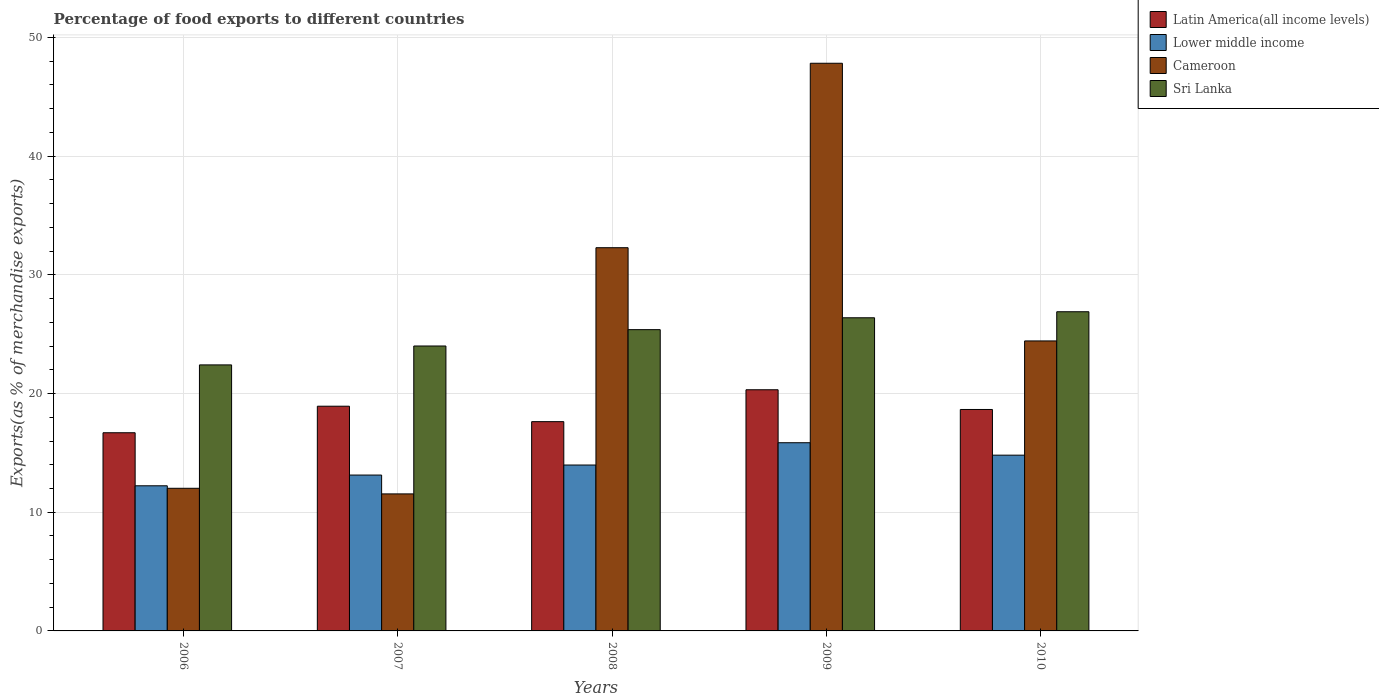How many bars are there on the 1st tick from the left?
Your answer should be compact. 4. How many bars are there on the 2nd tick from the right?
Offer a very short reply. 4. In how many cases, is the number of bars for a given year not equal to the number of legend labels?
Provide a short and direct response. 0. What is the percentage of exports to different countries in Sri Lanka in 2006?
Offer a very short reply. 22.41. Across all years, what is the maximum percentage of exports to different countries in Latin America(all income levels)?
Ensure brevity in your answer.  20.32. Across all years, what is the minimum percentage of exports to different countries in Sri Lanka?
Offer a terse response. 22.41. What is the total percentage of exports to different countries in Latin America(all income levels) in the graph?
Make the answer very short. 92.23. What is the difference between the percentage of exports to different countries in Sri Lanka in 2006 and that in 2008?
Make the answer very short. -2.97. What is the difference between the percentage of exports to different countries in Cameroon in 2007 and the percentage of exports to different countries in Lower middle income in 2010?
Provide a succinct answer. -3.26. What is the average percentage of exports to different countries in Sri Lanka per year?
Keep it short and to the point. 25.02. In the year 2007, what is the difference between the percentage of exports to different countries in Sri Lanka and percentage of exports to different countries in Cameroon?
Provide a short and direct response. 12.46. In how many years, is the percentage of exports to different countries in Latin America(all income levels) greater than 40 %?
Make the answer very short. 0. What is the ratio of the percentage of exports to different countries in Latin America(all income levels) in 2009 to that in 2010?
Offer a very short reply. 1.09. Is the percentage of exports to different countries in Sri Lanka in 2006 less than that in 2009?
Provide a short and direct response. Yes. Is the difference between the percentage of exports to different countries in Sri Lanka in 2006 and 2009 greater than the difference between the percentage of exports to different countries in Cameroon in 2006 and 2009?
Your answer should be compact. Yes. What is the difference between the highest and the second highest percentage of exports to different countries in Latin America(all income levels)?
Ensure brevity in your answer.  1.39. What is the difference between the highest and the lowest percentage of exports to different countries in Cameroon?
Your answer should be very brief. 36.28. In how many years, is the percentage of exports to different countries in Latin America(all income levels) greater than the average percentage of exports to different countries in Latin America(all income levels) taken over all years?
Make the answer very short. 3. Is the sum of the percentage of exports to different countries in Latin America(all income levels) in 2007 and 2009 greater than the maximum percentage of exports to different countries in Sri Lanka across all years?
Your answer should be compact. Yes. Is it the case that in every year, the sum of the percentage of exports to different countries in Lower middle income and percentage of exports to different countries in Latin America(all income levels) is greater than the sum of percentage of exports to different countries in Cameroon and percentage of exports to different countries in Sri Lanka?
Provide a succinct answer. No. What does the 3rd bar from the left in 2008 represents?
Ensure brevity in your answer.  Cameroon. What does the 4th bar from the right in 2009 represents?
Ensure brevity in your answer.  Latin America(all income levels). Is it the case that in every year, the sum of the percentage of exports to different countries in Cameroon and percentage of exports to different countries in Sri Lanka is greater than the percentage of exports to different countries in Lower middle income?
Keep it short and to the point. Yes. How many bars are there?
Make the answer very short. 20. How many years are there in the graph?
Your response must be concise. 5. What is the difference between two consecutive major ticks on the Y-axis?
Provide a short and direct response. 10. Are the values on the major ticks of Y-axis written in scientific E-notation?
Make the answer very short. No. How many legend labels are there?
Offer a terse response. 4. What is the title of the graph?
Keep it short and to the point. Percentage of food exports to different countries. What is the label or title of the Y-axis?
Ensure brevity in your answer.  Exports(as % of merchandise exports). What is the Exports(as % of merchandise exports) of Latin America(all income levels) in 2006?
Keep it short and to the point. 16.7. What is the Exports(as % of merchandise exports) in Lower middle income in 2006?
Provide a short and direct response. 12.23. What is the Exports(as % of merchandise exports) in Cameroon in 2006?
Keep it short and to the point. 12.02. What is the Exports(as % of merchandise exports) in Sri Lanka in 2006?
Ensure brevity in your answer.  22.41. What is the Exports(as % of merchandise exports) in Latin America(all income levels) in 2007?
Provide a succinct answer. 18.93. What is the Exports(as % of merchandise exports) in Lower middle income in 2007?
Keep it short and to the point. 13.13. What is the Exports(as % of merchandise exports) of Cameroon in 2007?
Your answer should be compact. 11.54. What is the Exports(as % of merchandise exports) in Sri Lanka in 2007?
Keep it short and to the point. 24. What is the Exports(as % of merchandise exports) of Latin America(all income levels) in 2008?
Offer a very short reply. 17.63. What is the Exports(as % of merchandise exports) of Lower middle income in 2008?
Keep it short and to the point. 13.98. What is the Exports(as % of merchandise exports) in Cameroon in 2008?
Offer a terse response. 32.29. What is the Exports(as % of merchandise exports) of Sri Lanka in 2008?
Keep it short and to the point. 25.38. What is the Exports(as % of merchandise exports) in Latin America(all income levels) in 2009?
Your answer should be very brief. 20.32. What is the Exports(as % of merchandise exports) of Lower middle income in 2009?
Give a very brief answer. 15.86. What is the Exports(as % of merchandise exports) in Cameroon in 2009?
Provide a short and direct response. 47.83. What is the Exports(as % of merchandise exports) of Sri Lanka in 2009?
Ensure brevity in your answer.  26.38. What is the Exports(as % of merchandise exports) in Latin America(all income levels) in 2010?
Ensure brevity in your answer.  18.66. What is the Exports(as % of merchandise exports) of Lower middle income in 2010?
Provide a succinct answer. 14.81. What is the Exports(as % of merchandise exports) of Cameroon in 2010?
Keep it short and to the point. 24.43. What is the Exports(as % of merchandise exports) in Sri Lanka in 2010?
Keep it short and to the point. 26.89. Across all years, what is the maximum Exports(as % of merchandise exports) of Latin America(all income levels)?
Your answer should be very brief. 20.32. Across all years, what is the maximum Exports(as % of merchandise exports) of Lower middle income?
Your answer should be compact. 15.86. Across all years, what is the maximum Exports(as % of merchandise exports) of Cameroon?
Keep it short and to the point. 47.83. Across all years, what is the maximum Exports(as % of merchandise exports) of Sri Lanka?
Provide a succinct answer. 26.89. Across all years, what is the minimum Exports(as % of merchandise exports) of Latin America(all income levels)?
Give a very brief answer. 16.7. Across all years, what is the minimum Exports(as % of merchandise exports) of Lower middle income?
Give a very brief answer. 12.23. Across all years, what is the minimum Exports(as % of merchandise exports) of Cameroon?
Offer a very short reply. 11.54. Across all years, what is the minimum Exports(as % of merchandise exports) in Sri Lanka?
Your answer should be compact. 22.41. What is the total Exports(as % of merchandise exports) of Latin America(all income levels) in the graph?
Your response must be concise. 92.23. What is the total Exports(as % of merchandise exports) of Lower middle income in the graph?
Offer a very short reply. 70. What is the total Exports(as % of merchandise exports) in Cameroon in the graph?
Provide a short and direct response. 128.1. What is the total Exports(as % of merchandise exports) of Sri Lanka in the graph?
Your answer should be very brief. 125.08. What is the difference between the Exports(as % of merchandise exports) in Latin America(all income levels) in 2006 and that in 2007?
Keep it short and to the point. -2.24. What is the difference between the Exports(as % of merchandise exports) in Lower middle income in 2006 and that in 2007?
Offer a terse response. -0.91. What is the difference between the Exports(as % of merchandise exports) of Cameroon in 2006 and that in 2007?
Give a very brief answer. 0.47. What is the difference between the Exports(as % of merchandise exports) of Sri Lanka in 2006 and that in 2007?
Your answer should be very brief. -1.59. What is the difference between the Exports(as % of merchandise exports) of Latin America(all income levels) in 2006 and that in 2008?
Make the answer very short. -0.93. What is the difference between the Exports(as % of merchandise exports) of Lower middle income in 2006 and that in 2008?
Your answer should be very brief. -1.75. What is the difference between the Exports(as % of merchandise exports) in Cameroon in 2006 and that in 2008?
Ensure brevity in your answer.  -20.27. What is the difference between the Exports(as % of merchandise exports) in Sri Lanka in 2006 and that in 2008?
Keep it short and to the point. -2.97. What is the difference between the Exports(as % of merchandise exports) in Latin America(all income levels) in 2006 and that in 2009?
Offer a very short reply. -3.62. What is the difference between the Exports(as % of merchandise exports) of Lower middle income in 2006 and that in 2009?
Keep it short and to the point. -3.63. What is the difference between the Exports(as % of merchandise exports) of Cameroon in 2006 and that in 2009?
Give a very brief answer. -35.81. What is the difference between the Exports(as % of merchandise exports) in Sri Lanka in 2006 and that in 2009?
Your response must be concise. -3.97. What is the difference between the Exports(as % of merchandise exports) in Latin America(all income levels) in 2006 and that in 2010?
Your answer should be very brief. -1.96. What is the difference between the Exports(as % of merchandise exports) of Lower middle income in 2006 and that in 2010?
Give a very brief answer. -2.58. What is the difference between the Exports(as % of merchandise exports) of Cameroon in 2006 and that in 2010?
Provide a short and direct response. -12.41. What is the difference between the Exports(as % of merchandise exports) of Sri Lanka in 2006 and that in 2010?
Ensure brevity in your answer.  -4.48. What is the difference between the Exports(as % of merchandise exports) of Latin America(all income levels) in 2007 and that in 2008?
Provide a succinct answer. 1.3. What is the difference between the Exports(as % of merchandise exports) of Lower middle income in 2007 and that in 2008?
Your response must be concise. -0.85. What is the difference between the Exports(as % of merchandise exports) of Cameroon in 2007 and that in 2008?
Your answer should be very brief. -20.74. What is the difference between the Exports(as % of merchandise exports) of Sri Lanka in 2007 and that in 2008?
Make the answer very short. -1.38. What is the difference between the Exports(as % of merchandise exports) in Latin America(all income levels) in 2007 and that in 2009?
Make the answer very short. -1.39. What is the difference between the Exports(as % of merchandise exports) of Lower middle income in 2007 and that in 2009?
Provide a succinct answer. -2.72. What is the difference between the Exports(as % of merchandise exports) of Cameroon in 2007 and that in 2009?
Offer a very short reply. -36.28. What is the difference between the Exports(as % of merchandise exports) in Sri Lanka in 2007 and that in 2009?
Your answer should be very brief. -2.38. What is the difference between the Exports(as % of merchandise exports) of Latin America(all income levels) in 2007 and that in 2010?
Provide a succinct answer. 0.28. What is the difference between the Exports(as % of merchandise exports) of Lower middle income in 2007 and that in 2010?
Provide a short and direct response. -1.67. What is the difference between the Exports(as % of merchandise exports) of Cameroon in 2007 and that in 2010?
Your response must be concise. -12.89. What is the difference between the Exports(as % of merchandise exports) in Sri Lanka in 2007 and that in 2010?
Your response must be concise. -2.89. What is the difference between the Exports(as % of merchandise exports) of Latin America(all income levels) in 2008 and that in 2009?
Provide a succinct answer. -2.69. What is the difference between the Exports(as % of merchandise exports) of Lower middle income in 2008 and that in 2009?
Offer a terse response. -1.88. What is the difference between the Exports(as % of merchandise exports) of Cameroon in 2008 and that in 2009?
Your answer should be very brief. -15.54. What is the difference between the Exports(as % of merchandise exports) of Sri Lanka in 2008 and that in 2009?
Provide a short and direct response. -1. What is the difference between the Exports(as % of merchandise exports) in Latin America(all income levels) in 2008 and that in 2010?
Your response must be concise. -1.03. What is the difference between the Exports(as % of merchandise exports) in Lower middle income in 2008 and that in 2010?
Provide a succinct answer. -0.83. What is the difference between the Exports(as % of merchandise exports) in Cameroon in 2008 and that in 2010?
Your response must be concise. 7.85. What is the difference between the Exports(as % of merchandise exports) of Sri Lanka in 2008 and that in 2010?
Keep it short and to the point. -1.51. What is the difference between the Exports(as % of merchandise exports) of Latin America(all income levels) in 2009 and that in 2010?
Offer a terse response. 1.66. What is the difference between the Exports(as % of merchandise exports) in Lower middle income in 2009 and that in 2010?
Your answer should be compact. 1.05. What is the difference between the Exports(as % of merchandise exports) in Cameroon in 2009 and that in 2010?
Offer a terse response. 23.39. What is the difference between the Exports(as % of merchandise exports) of Sri Lanka in 2009 and that in 2010?
Ensure brevity in your answer.  -0.51. What is the difference between the Exports(as % of merchandise exports) in Latin America(all income levels) in 2006 and the Exports(as % of merchandise exports) in Lower middle income in 2007?
Your answer should be very brief. 3.56. What is the difference between the Exports(as % of merchandise exports) of Latin America(all income levels) in 2006 and the Exports(as % of merchandise exports) of Cameroon in 2007?
Your answer should be compact. 5.15. What is the difference between the Exports(as % of merchandise exports) in Latin America(all income levels) in 2006 and the Exports(as % of merchandise exports) in Sri Lanka in 2007?
Provide a short and direct response. -7.31. What is the difference between the Exports(as % of merchandise exports) in Lower middle income in 2006 and the Exports(as % of merchandise exports) in Cameroon in 2007?
Provide a succinct answer. 0.68. What is the difference between the Exports(as % of merchandise exports) of Lower middle income in 2006 and the Exports(as % of merchandise exports) of Sri Lanka in 2007?
Provide a short and direct response. -11.78. What is the difference between the Exports(as % of merchandise exports) in Cameroon in 2006 and the Exports(as % of merchandise exports) in Sri Lanka in 2007?
Keep it short and to the point. -11.99. What is the difference between the Exports(as % of merchandise exports) in Latin America(all income levels) in 2006 and the Exports(as % of merchandise exports) in Lower middle income in 2008?
Provide a succinct answer. 2.72. What is the difference between the Exports(as % of merchandise exports) in Latin America(all income levels) in 2006 and the Exports(as % of merchandise exports) in Cameroon in 2008?
Keep it short and to the point. -15.59. What is the difference between the Exports(as % of merchandise exports) of Latin America(all income levels) in 2006 and the Exports(as % of merchandise exports) of Sri Lanka in 2008?
Your answer should be very brief. -8.69. What is the difference between the Exports(as % of merchandise exports) of Lower middle income in 2006 and the Exports(as % of merchandise exports) of Cameroon in 2008?
Ensure brevity in your answer.  -20.06. What is the difference between the Exports(as % of merchandise exports) of Lower middle income in 2006 and the Exports(as % of merchandise exports) of Sri Lanka in 2008?
Your answer should be very brief. -13.16. What is the difference between the Exports(as % of merchandise exports) of Cameroon in 2006 and the Exports(as % of merchandise exports) of Sri Lanka in 2008?
Provide a succinct answer. -13.37. What is the difference between the Exports(as % of merchandise exports) in Latin America(all income levels) in 2006 and the Exports(as % of merchandise exports) in Lower middle income in 2009?
Your response must be concise. 0.84. What is the difference between the Exports(as % of merchandise exports) in Latin America(all income levels) in 2006 and the Exports(as % of merchandise exports) in Cameroon in 2009?
Your response must be concise. -31.13. What is the difference between the Exports(as % of merchandise exports) of Latin America(all income levels) in 2006 and the Exports(as % of merchandise exports) of Sri Lanka in 2009?
Your answer should be very brief. -9.69. What is the difference between the Exports(as % of merchandise exports) in Lower middle income in 2006 and the Exports(as % of merchandise exports) in Cameroon in 2009?
Offer a very short reply. -35.6. What is the difference between the Exports(as % of merchandise exports) of Lower middle income in 2006 and the Exports(as % of merchandise exports) of Sri Lanka in 2009?
Ensure brevity in your answer.  -14.16. What is the difference between the Exports(as % of merchandise exports) of Cameroon in 2006 and the Exports(as % of merchandise exports) of Sri Lanka in 2009?
Offer a terse response. -14.37. What is the difference between the Exports(as % of merchandise exports) of Latin America(all income levels) in 2006 and the Exports(as % of merchandise exports) of Lower middle income in 2010?
Ensure brevity in your answer.  1.89. What is the difference between the Exports(as % of merchandise exports) of Latin America(all income levels) in 2006 and the Exports(as % of merchandise exports) of Cameroon in 2010?
Give a very brief answer. -7.74. What is the difference between the Exports(as % of merchandise exports) in Latin America(all income levels) in 2006 and the Exports(as % of merchandise exports) in Sri Lanka in 2010?
Keep it short and to the point. -10.2. What is the difference between the Exports(as % of merchandise exports) in Lower middle income in 2006 and the Exports(as % of merchandise exports) in Cameroon in 2010?
Ensure brevity in your answer.  -12.2. What is the difference between the Exports(as % of merchandise exports) of Lower middle income in 2006 and the Exports(as % of merchandise exports) of Sri Lanka in 2010?
Make the answer very short. -14.66. What is the difference between the Exports(as % of merchandise exports) of Cameroon in 2006 and the Exports(as % of merchandise exports) of Sri Lanka in 2010?
Ensure brevity in your answer.  -14.87. What is the difference between the Exports(as % of merchandise exports) of Latin America(all income levels) in 2007 and the Exports(as % of merchandise exports) of Lower middle income in 2008?
Give a very brief answer. 4.95. What is the difference between the Exports(as % of merchandise exports) of Latin America(all income levels) in 2007 and the Exports(as % of merchandise exports) of Cameroon in 2008?
Your response must be concise. -13.35. What is the difference between the Exports(as % of merchandise exports) in Latin America(all income levels) in 2007 and the Exports(as % of merchandise exports) in Sri Lanka in 2008?
Your answer should be compact. -6.45. What is the difference between the Exports(as % of merchandise exports) in Lower middle income in 2007 and the Exports(as % of merchandise exports) in Cameroon in 2008?
Ensure brevity in your answer.  -19.15. What is the difference between the Exports(as % of merchandise exports) of Lower middle income in 2007 and the Exports(as % of merchandise exports) of Sri Lanka in 2008?
Your response must be concise. -12.25. What is the difference between the Exports(as % of merchandise exports) of Cameroon in 2007 and the Exports(as % of merchandise exports) of Sri Lanka in 2008?
Give a very brief answer. -13.84. What is the difference between the Exports(as % of merchandise exports) of Latin America(all income levels) in 2007 and the Exports(as % of merchandise exports) of Lower middle income in 2009?
Your answer should be compact. 3.08. What is the difference between the Exports(as % of merchandise exports) in Latin America(all income levels) in 2007 and the Exports(as % of merchandise exports) in Cameroon in 2009?
Ensure brevity in your answer.  -28.89. What is the difference between the Exports(as % of merchandise exports) in Latin America(all income levels) in 2007 and the Exports(as % of merchandise exports) in Sri Lanka in 2009?
Provide a succinct answer. -7.45. What is the difference between the Exports(as % of merchandise exports) of Lower middle income in 2007 and the Exports(as % of merchandise exports) of Cameroon in 2009?
Give a very brief answer. -34.69. What is the difference between the Exports(as % of merchandise exports) in Lower middle income in 2007 and the Exports(as % of merchandise exports) in Sri Lanka in 2009?
Offer a very short reply. -13.25. What is the difference between the Exports(as % of merchandise exports) in Cameroon in 2007 and the Exports(as % of merchandise exports) in Sri Lanka in 2009?
Offer a terse response. -14.84. What is the difference between the Exports(as % of merchandise exports) in Latin America(all income levels) in 2007 and the Exports(as % of merchandise exports) in Lower middle income in 2010?
Ensure brevity in your answer.  4.13. What is the difference between the Exports(as % of merchandise exports) of Latin America(all income levels) in 2007 and the Exports(as % of merchandise exports) of Cameroon in 2010?
Make the answer very short. -5.5. What is the difference between the Exports(as % of merchandise exports) of Latin America(all income levels) in 2007 and the Exports(as % of merchandise exports) of Sri Lanka in 2010?
Make the answer very short. -7.96. What is the difference between the Exports(as % of merchandise exports) in Lower middle income in 2007 and the Exports(as % of merchandise exports) in Cameroon in 2010?
Make the answer very short. -11.3. What is the difference between the Exports(as % of merchandise exports) of Lower middle income in 2007 and the Exports(as % of merchandise exports) of Sri Lanka in 2010?
Your answer should be compact. -13.76. What is the difference between the Exports(as % of merchandise exports) of Cameroon in 2007 and the Exports(as % of merchandise exports) of Sri Lanka in 2010?
Your answer should be very brief. -15.35. What is the difference between the Exports(as % of merchandise exports) of Latin America(all income levels) in 2008 and the Exports(as % of merchandise exports) of Lower middle income in 2009?
Your response must be concise. 1.78. What is the difference between the Exports(as % of merchandise exports) in Latin America(all income levels) in 2008 and the Exports(as % of merchandise exports) in Cameroon in 2009?
Offer a terse response. -30.19. What is the difference between the Exports(as % of merchandise exports) in Latin America(all income levels) in 2008 and the Exports(as % of merchandise exports) in Sri Lanka in 2009?
Make the answer very short. -8.75. What is the difference between the Exports(as % of merchandise exports) in Lower middle income in 2008 and the Exports(as % of merchandise exports) in Cameroon in 2009?
Offer a terse response. -33.85. What is the difference between the Exports(as % of merchandise exports) of Lower middle income in 2008 and the Exports(as % of merchandise exports) of Sri Lanka in 2009?
Your response must be concise. -12.41. What is the difference between the Exports(as % of merchandise exports) of Cameroon in 2008 and the Exports(as % of merchandise exports) of Sri Lanka in 2009?
Offer a very short reply. 5.9. What is the difference between the Exports(as % of merchandise exports) in Latin America(all income levels) in 2008 and the Exports(as % of merchandise exports) in Lower middle income in 2010?
Keep it short and to the point. 2.82. What is the difference between the Exports(as % of merchandise exports) of Latin America(all income levels) in 2008 and the Exports(as % of merchandise exports) of Cameroon in 2010?
Provide a succinct answer. -6.8. What is the difference between the Exports(as % of merchandise exports) of Latin America(all income levels) in 2008 and the Exports(as % of merchandise exports) of Sri Lanka in 2010?
Provide a short and direct response. -9.26. What is the difference between the Exports(as % of merchandise exports) in Lower middle income in 2008 and the Exports(as % of merchandise exports) in Cameroon in 2010?
Provide a short and direct response. -10.45. What is the difference between the Exports(as % of merchandise exports) of Lower middle income in 2008 and the Exports(as % of merchandise exports) of Sri Lanka in 2010?
Your answer should be very brief. -12.91. What is the difference between the Exports(as % of merchandise exports) in Cameroon in 2008 and the Exports(as % of merchandise exports) in Sri Lanka in 2010?
Provide a succinct answer. 5.39. What is the difference between the Exports(as % of merchandise exports) in Latin America(all income levels) in 2009 and the Exports(as % of merchandise exports) in Lower middle income in 2010?
Your response must be concise. 5.51. What is the difference between the Exports(as % of merchandise exports) in Latin America(all income levels) in 2009 and the Exports(as % of merchandise exports) in Cameroon in 2010?
Offer a terse response. -4.11. What is the difference between the Exports(as % of merchandise exports) of Latin America(all income levels) in 2009 and the Exports(as % of merchandise exports) of Sri Lanka in 2010?
Keep it short and to the point. -6.57. What is the difference between the Exports(as % of merchandise exports) in Lower middle income in 2009 and the Exports(as % of merchandise exports) in Cameroon in 2010?
Your response must be concise. -8.58. What is the difference between the Exports(as % of merchandise exports) of Lower middle income in 2009 and the Exports(as % of merchandise exports) of Sri Lanka in 2010?
Provide a succinct answer. -11.04. What is the difference between the Exports(as % of merchandise exports) of Cameroon in 2009 and the Exports(as % of merchandise exports) of Sri Lanka in 2010?
Ensure brevity in your answer.  20.93. What is the average Exports(as % of merchandise exports) in Latin America(all income levels) per year?
Keep it short and to the point. 18.45. What is the average Exports(as % of merchandise exports) of Lower middle income per year?
Give a very brief answer. 14. What is the average Exports(as % of merchandise exports) of Cameroon per year?
Make the answer very short. 25.62. What is the average Exports(as % of merchandise exports) of Sri Lanka per year?
Provide a succinct answer. 25.02. In the year 2006, what is the difference between the Exports(as % of merchandise exports) of Latin America(all income levels) and Exports(as % of merchandise exports) of Lower middle income?
Ensure brevity in your answer.  4.47. In the year 2006, what is the difference between the Exports(as % of merchandise exports) in Latin America(all income levels) and Exports(as % of merchandise exports) in Cameroon?
Your answer should be compact. 4.68. In the year 2006, what is the difference between the Exports(as % of merchandise exports) of Latin America(all income levels) and Exports(as % of merchandise exports) of Sri Lanka?
Offer a terse response. -5.72. In the year 2006, what is the difference between the Exports(as % of merchandise exports) in Lower middle income and Exports(as % of merchandise exports) in Cameroon?
Your answer should be compact. 0.21. In the year 2006, what is the difference between the Exports(as % of merchandise exports) in Lower middle income and Exports(as % of merchandise exports) in Sri Lanka?
Your answer should be very brief. -10.19. In the year 2006, what is the difference between the Exports(as % of merchandise exports) of Cameroon and Exports(as % of merchandise exports) of Sri Lanka?
Provide a succinct answer. -10.39. In the year 2007, what is the difference between the Exports(as % of merchandise exports) in Latin America(all income levels) and Exports(as % of merchandise exports) in Lower middle income?
Provide a short and direct response. 5.8. In the year 2007, what is the difference between the Exports(as % of merchandise exports) in Latin America(all income levels) and Exports(as % of merchandise exports) in Cameroon?
Offer a terse response. 7.39. In the year 2007, what is the difference between the Exports(as % of merchandise exports) of Latin America(all income levels) and Exports(as % of merchandise exports) of Sri Lanka?
Your answer should be compact. -5.07. In the year 2007, what is the difference between the Exports(as % of merchandise exports) of Lower middle income and Exports(as % of merchandise exports) of Cameroon?
Keep it short and to the point. 1.59. In the year 2007, what is the difference between the Exports(as % of merchandise exports) of Lower middle income and Exports(as % of merchandise exports) of Sri Lanka?
Make the answer very short. -10.87. In the year 2007, what is the difference between the Exports(as % of merchandise exports) of Cameroon and Exports(as % of merchandise exports) of Sri Lanka?
Offer a very short reply. -12.46. In the year 2008, what is the difference between the Exports(as % of merchandise exports) of Latin America(all income levels) and Exports(as % of merchandise exports) of Lower middle income?
Your response must be concise. 3.65. In the year 2008, what is the difference between the Exports(as % of merchandise exports) in Latin America(all income levels) and Exports(as % of merchandise exports) in Cameroon?
Make the answer very short. -14.65. In the year 2008, what is the difference between the Exports(as % of merchandise exports) in Latin America(all income levels) and Exports(as % of merchandise exports) in Sri Lanka?
Ensure brevity in your answer.  -7.75. In the year 2008, what is the difference between the Exports(as % of merchandise exports) of Lower middle income and Exports(as % of merchandise exports) of Cameroon?
Keep it short and to the point. -18.31. In the year 2008, what is the difference between the Exports(as % of merchandise exports) in Lower middle income and Exports(as % of merchandise exports) in Sri Lanka?
Your answer should be compact. -11.41. In the year 2008, what is the difference between the Exports(as % of merchandise exports) of Cameroon and Exports(as % of merchandise exports) of Sri Lanka?
Keep it short and to the point. 6.9. In the year 2009, what is the difference between the Exports(as % of merchandise exports) of Latin America(all income levels) and Exports(as % of merchandise exports) of Lower middle income?
Your answer should be very brief. 4.46. In the year 2009, what is the difference between the Exports(as % of merchandise exports) of Latin America(all income levels) and Exports(as % of merchandise exports) of Cameroon?
Offer a very short reply. -27.51. In the year 2009, what is the difference between the Exports(as % of merchandise exports) in Latin America(all income levels) and Exports(as % of merchandise exports) in Sri Lanka?
Make the answer very short. -6.07. In the year 2009, what is the difference between the Exports(as % of merchandise exports) of Lower middle income and Exports(as % of merchandise exports) of Cameroon?
Your response must be concise. -31.97. In the year 2009, what is the difference between the Exports(as % of merchandise exports) in Lower middle income and Exports(as % of merchandise exports) in Sri Lanka?
Provide a succinct answer. -10.53. In the year 2009, what is the difference between the Exports(as % of merchandise exports) in Cameroon and Exports(as % of merchandise exports) in Sri Lanka?
Your response must be concise. 21.44. In the year 2010, what is the difference between the Exports(as % of merchandise exports) in Latin America(all income levels) and Exports(as % of merchandise exports) in Lower middle income?
Provide a succinct answer. 3.85. In the year 2010, what is the difference between the Exports(as % of merchandise exports) in Latin America(all income levels) and Exports(as % of merchandise exports) in Cameroon?
Your response must be concise. -5.78. In the year 2010, what is the difference between the Exports(as % of merchandise exports) in Latin America(all income levels) and Exports(as % of merchandise exports) in Sri Lanka?
Your answer should be compact. -8.24. In the year 2010, what is the difference between the Exports(as % of merchandise exports) in Lower middle income and Exports(as % of merchandise exports) in Cameroon?
Provide a succinct answer. -9.62. In the year 2010, what is the difference between the Exports(as % of merchandise exports) in Lower middle income and Exports(as % of merchandise exports) in Sri Lanka?
Keep it short and to the point. -12.08. In the year 2010, what is the difference between the Exports(as % of merchandise exports) in Cameroon and Exports(as % of merchandise exports) in Sri Lanka?
Your answer should be very brief. -2.46. What is the ratio of the Exports(as % of merchandise exports) of Latin America(all income levels) in 2006 to that in 2007?
Your answer should be very brief. 0.88. What is the ratio of the Exports(as % of merchandise exports) of Lower middle income in 2006 to that in 2007?
Provide a succinct answer. 0.93. What is the ratio of the Exports(as % of merchandise exports) of Cameroon in 2006 to that in 2007?
Provide a succinct answer. 1.04. What is the ratio of the Exports(as % of merchandise exports) of Sri Lanka in 2006 to that in 2007?
Offer a terse response. 0.93. What is the ratio of the Exports(as % of merchandise exports) in Latin America(all income levels) in 2006 to that in 2008?
Your answer should be compact. 0.95. What is the ratio of the Exports(as % of merchandise exports) in Lower middle income in 2006 to that in 2008?
Your answer should be compact. 0.87. What is the ratio of the Exports(as % of merchandise exports) of Cameroon in 2006 to that in 2008?
Offer a terse response. 0.37. What is the ratio of the Exports(as % of merchandise exports) of Sri Lanka in 2006 to that in 2008?
Ensure brevity in your answer.  0.88. What is the ratio of the Exports(as % of merchandise exports) of Latin America(all income levels) in 2006 to that in 2009?
Keep it short and to the point. 0.82. What is the ratio of the Exports(as % of merchandise exports) in Lower middle income in 2006 to that in 2009?
Make the answer very short. 0.77. What is the ratio of the Exports(as % of merchandise exports) in Cameroon in 2006 to that in 2009?
Offer a very short reply. 0.25. What is the ratio of the Exports(as % of merchandise exports) of Sri Lanka in 2006 to that in 2009?
Your response must be concise. 0.85. What is the ratio of the Exports(as % of merchandise exports) in Latin America(all income levels) in 2006 to that in 2010?
Your answer should be very brief. 0.89. What is the ratio of the Exports(as % of merchandise exports) in Lower middle income in 2006 to that in 2010?
Offer a terse response. 0.83. What is the ratio of the Exports(as % of merchandise exports) of Cameroon in 2006 to that in 2010?
Keep it short and to the point. 0.49. What is the ratio of the Exports(as % of merchandise exports) in Sri Lanka in 2006 to that in 2010?
Give a very brief answer. 0.83. What is the ratio of the Exports(as % of merchandise exports) in Latin America(all income levels) in 2007 to that in 2008?
Keep it short and to the point. 1.07. What is the ratio of the Exports(as % of merchandise exports) of Lower middle income in 2007 to that in 2008?
Your answer should be very brief. 0.94. What is the ratio of the Exports(as % of merchandise exports) of Cameroon in 2007 to that in 2008?
Give a very brief answer. 0.36. What is the ratio of the Exports(as % of merchandise exports) of Sri Lanka in 2007 to that in 2008?
Offer a very short reply. 0.95. What is the ratio of the Exports(as % of merchandise exports) of Latin America(all income levels) in 2007 to that in 2009?
Give a very brief answer. 0.93. What is the ratio of the Exports(as % of merchandise exports) in Lower middle income in 2007 to that in 2009?
Provide a succinct answer. 0.83. What is the ratio of the Exports(as % of merchandise exports) in Cameroon in 2007 to that in 2009?
Your answer should be very brief. 0.24. What is the ratio of the Exports(as % of merchandise exports) of Sri Lanka in 2007 to that in 2009?
Give a very brief answer. 0.91. What is the ratio of the Exports(as % of merchandise exports) of Latin America(all income levels) in 2007 to that in 2010?
Make the answer very short. 1.01. What is the ratio of the Exports(as % of merchandise exports) of Lower middle income in 2007 to that in 2010?
Make the answer very short. 0.89. What is the ratio of the Exports(as % of merchandise exports) in Cameroon in 2007 to that in 2010?
Make the answer very short. 0.47. What is the ratio of the Exports(as % of merchandise exports) in Sri Lanka in 2007 to that in 2010?
Your answer should be very brief. 0.89. What is the ratio of the Exports(as % of merchandise exports) of Latin America(all income levels) in 2008 to that in 2009?
Your answer should be compact. 0.87. What is the ratio of the Exports(as % of merchandise exports) of Lower middle income in 2008 to that in 2009?
Give a very brief answer. 0.88. What is the ratio of the Exports(as % of merchandise exports) in Cameroon in 2008 to that in 2009?
Provide a succinct answer. 0.68. What is the ratio of the Exports(as % of merchandise exports) of Sri Lanka in 2008 to that in 2009?
Ensure brevity in your answer.  0.96. What is the ratio of the Exports(as % of merchandise exports) in Latin America(all income levels) in 2008 to that in 2010?
Make the answer very short. 0.95. What is the ratio of the Exports(as % of merchandise exports) of Lower middle income in 2008 to that in 2010?
Offer a terse response. 0.94. What is the ratio of the Exports(as % of merchandise exports) in Cameroon in 2008 to that in 2010?
Your answer should be compact. 1.32. What is the ratio of the Exports(as % of merchandise exports) of Sri Lanka in 2008 to that in 2010?
Your response must be concise. 0.94. What is the ratio of the Exports(as % of merchandise exports) of Latin America(all income levels) in 2009 to that in 2010?
Keep it short and to the point. 1.09. What is the ratio of the Exports(as % of merchandise exports) of Lower middle income in 2009 to that in 2010?
Offer a very short reply. 1.07. What is the ratio of the Exports(as % of merchandise exports) in Cameroon in 2009 to that in 2010?
Keep it short and to the point. 1.96. What is the ratio of the Exports(as % of merchandise exports) in Sri Lanka in 2009 to that in 2010?
Your answer should be very brief. 0.98. What is the difference between the highest and the second highest Exports(as % of merchandise exports) of Latin America(all income levels)?
Your answer should be very brief. 1.39. What is the difference between the highest and the second highest Exports(as % of merchandise exports) of Lower middle income?
Your response must be concise. 1.05. What is the difference between the highest and the second highest Exports(as % of merchandise exports) of Cameroon?
Your response must be concise. 15.54. What is the difference between the highest and the second highest Exports(as % of merchandise exports) of Sri Lanka?
Offer a very short reply. 0.51. What is the difference between the highest and the lowest Exports(as % of merchandise exports) in Latin America(all income levels)?
Your answer should be compact. 3.62. What is the difference between the highest and the lowest Exports(as % of merchandise exports) in Lower middle income?
Your answer should be compact. 3.63. What is the difference between the highest and the lowest Exports(as % of merchandise exports) of Cameroon?
Offer a very short reply. 36.28. What is the difference between the highest and the lowest Exports(as % of merchandise exports) in Sri Lanka?
Give a very brief answer. 4.48. 